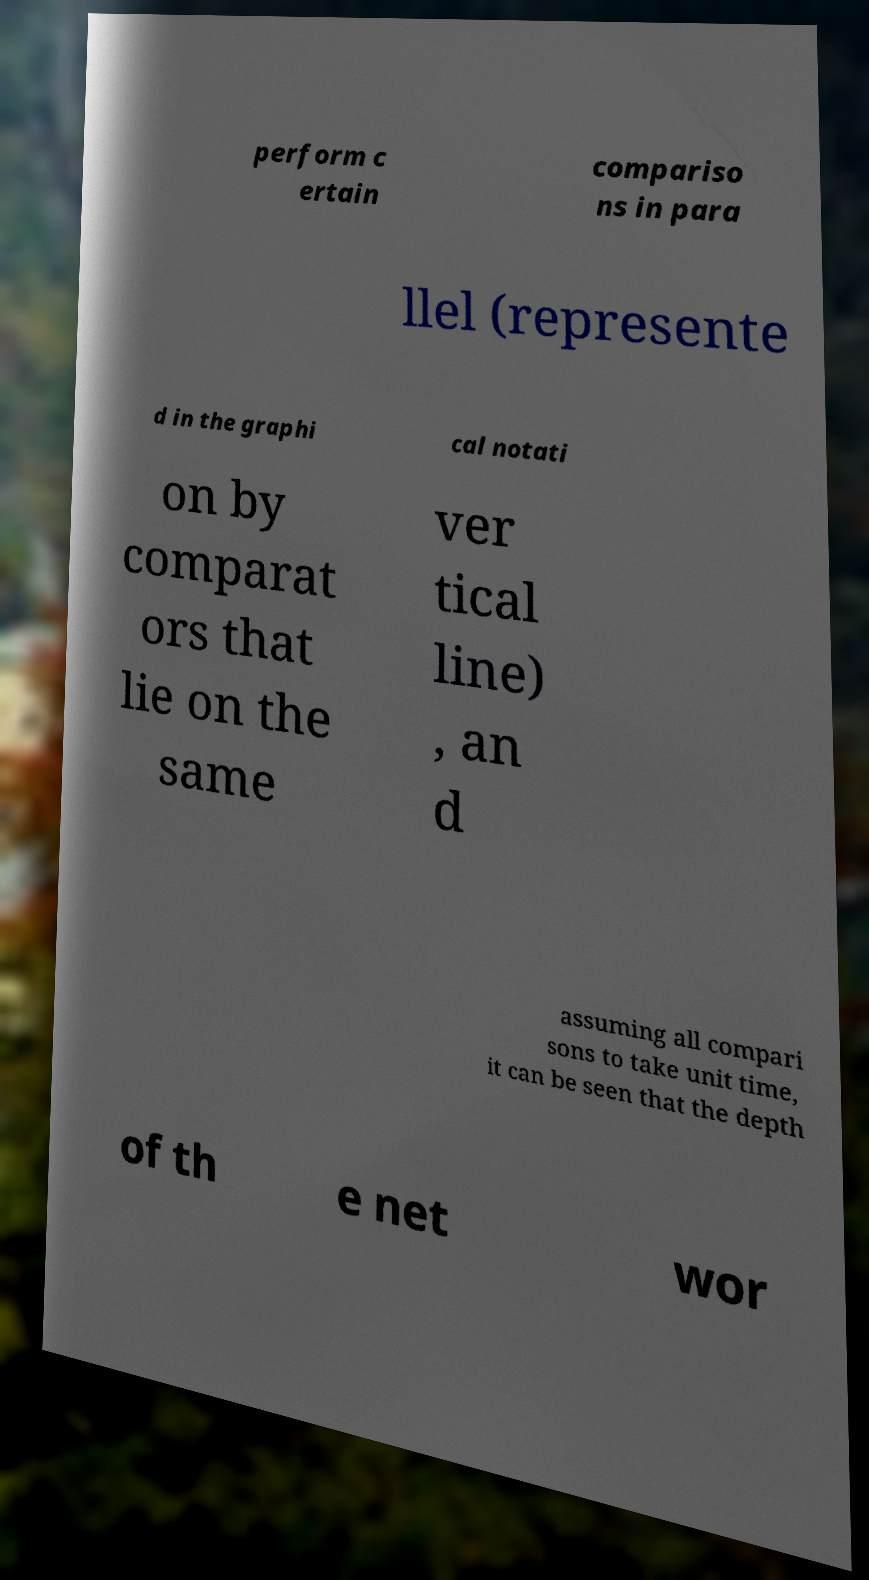What messages or text are displayed in this image? I need them in a readable, typed format. perform c ertain compariso ns in para llel (represente d in the graphi cal notati on by comparat ors that lie on the same ver tical line) , an d assuming all compari sons to take unit time, it can be seen that the depth of th e net wor 